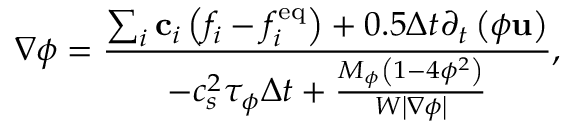<formula> <loc_0><loc_0><loc_500><loc_500>\nabla \phi = \frac { { \sum _ { i } { { { c } _ { i } } \left ( { { f _ { i } } - f _ { i } ^ { e q } } \right ) } + 0 . 5 \Delta t { \partial _ { t } } \left ( { \phi { u } } \right ) } } { { - c _ { s } ^ { 2 } { \tau _ { \phi } } \Delta t + \frac { { { M _ { \phi } } \left ( { 1 - 4 { \phi ^ { 2 } } } \right ) } } { { W \left | { \nabla \phi } \right | } } } } ,</formula> 